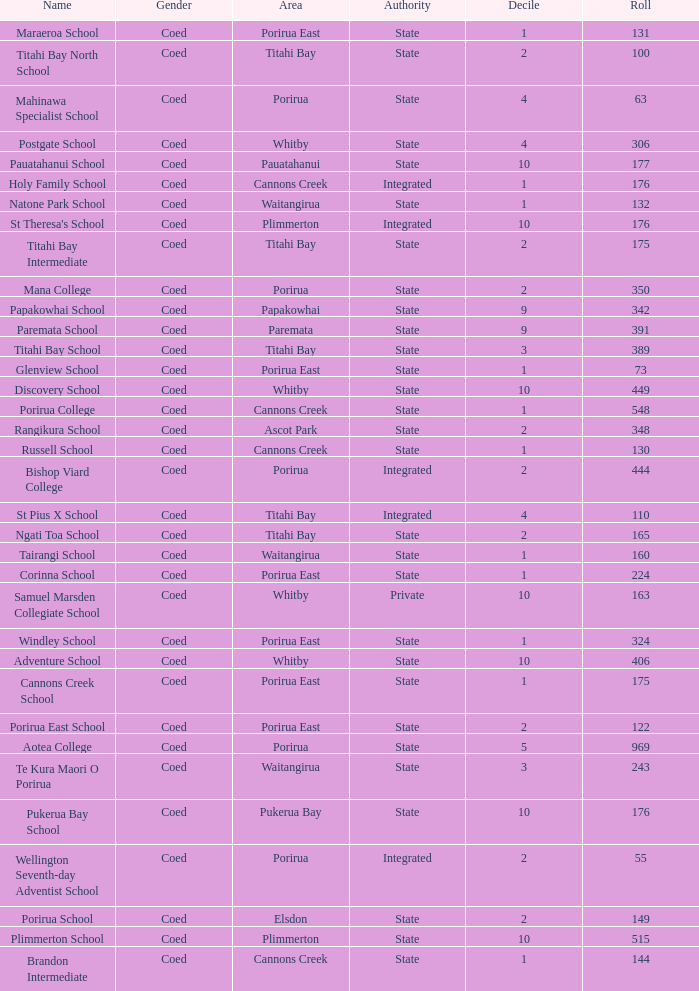What is the roll of Bishop Viard College (An Integrated College), which has a decile larger than 1? 1.0. 